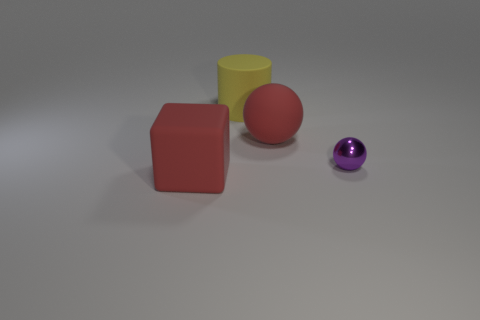How big is the red matte object that is in front of the metallic sphere?
Your answer should be compact. Large. There is a red object on the left side of the large red ball; is there a large red object behind it?
Your answer should be compact. Yes. Are the red object left of the big red rubber ball and the red sphere made of the same material?
Offer a terse response. Yes. How many large rubber objects are on the left side of the big rubber ball and behind the purple ball?
Provide a succinct answer. 1. How many large yellow cylinders have the same material as the tiny purple sphere?
Your answer should be compact. 0. There is a sphere that is made of the same material as the large red cube; what color is it?
Provide a succinct answer. Red. Is the number of yellow matte cylinders less than the number of blue metal cubes?
Your response must be concise. No. There is a red thing in front of the large red object behind the thing that is left of the yellow matte thing; what is its material?
Offer a terse response. Rubber. What material is the large sphere?
Your answer should be very brief. Rubber. Do the shiny ball that is behind the large matte cube and the large rubber object that is on the right side of the rubber cylinder have the same color?
Make the answer very short. No. 